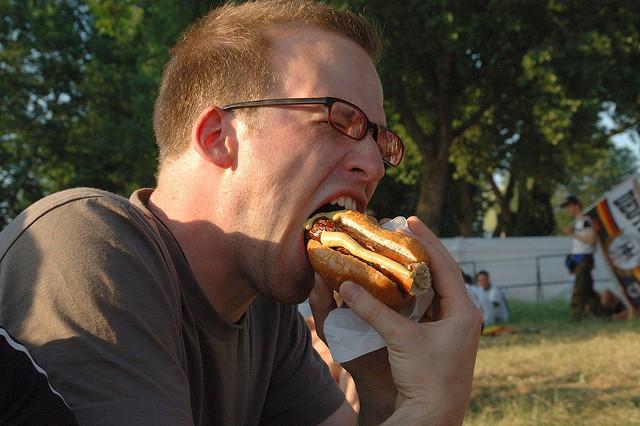Is he wearing glasses on his forehead?
Keep it brief. No. What is the condiment on the hotdog?
Write a very short answer. Mustard. Is this a city scene?
Short answer required. No. Is the man wearing glasses?
Be succinct. Yes. What is the man eating?
Concise answer only. Hot dog. 